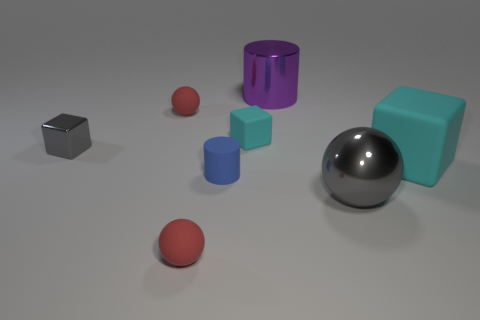Can you describe the spatial arrangement of the objects in the image? Certainly! The image showcases a collection of geometric shapes placed on a flat surface. On the left, there's a small, shiny silver cube. Moving rightward, there are three spheres in a diagonal arrangement; the two smaller spheres are a matte red color, and the larger one is shiny silver. Further right, there's a large teal cube and, next to it, a large purple cylinder. Closest to the front is a small blue cylinder. All objects cast soft shadows, indicating a source of light from above. 